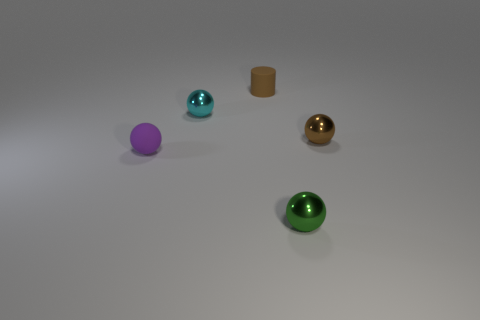Subtract all tiny brown balls. How many balls are left? 3 Subtract all green spheres. How many spheres are left? 3 Add 1 brown spheres. How many objects exist? 6 Subtract all gray balls. Subtract all gray cubes. How many balls are left? 4 Subtract all balls. How many objects are left? 1 Subtract all small brown spheres. Subtract all small green objects. How many objects are left? 3 Add 3 small brown shiny objects. How many small brown shiny objects are left? 4 Add 5 brown metal balls. How many brown metal balls exist? 6 Subtract 0 yellow cylinders. How many objects are left? 5 